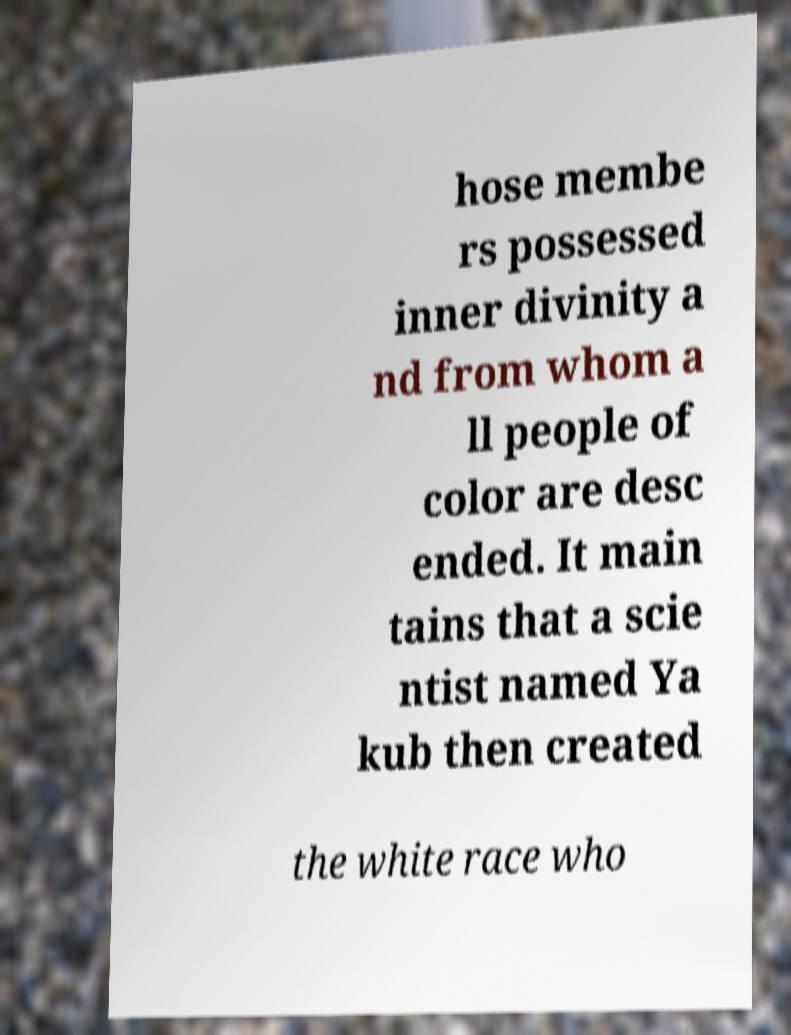Please identify and transcribe the text found in this image. hose membe rs possessed inner divinity a nd from whom a ll people of color are desc ended. It main tains that a scie ntist named Ya kub then created the white race who 